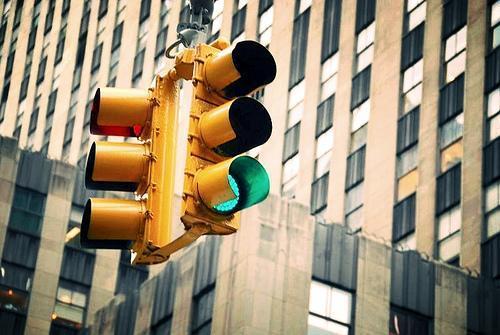How many lights are there?
Give a very brief answer. 2. 